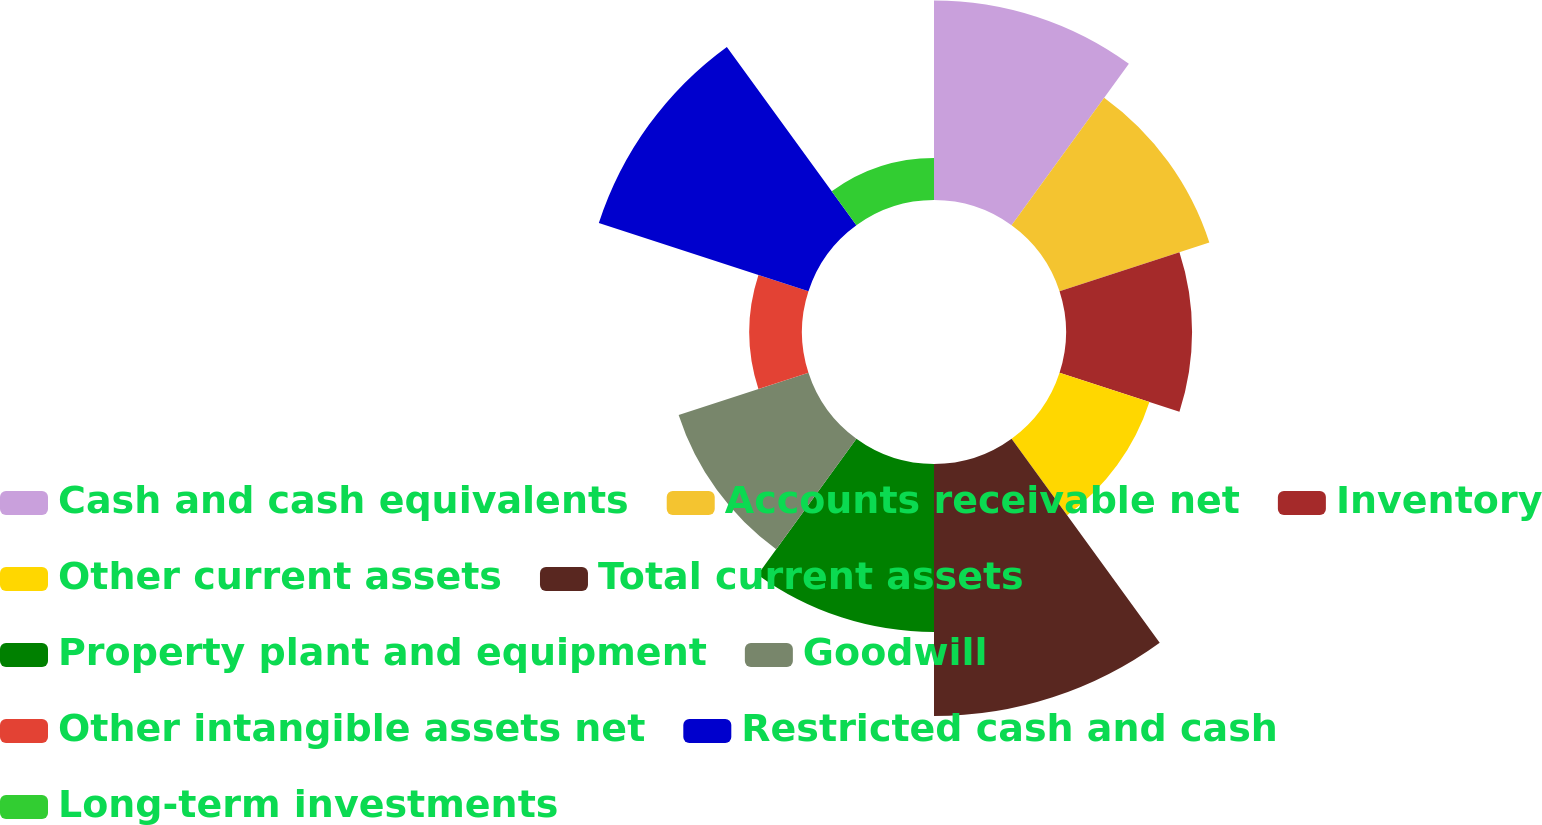Convert chart. <chart><loc_0><loc_0><loc_500><loc_500><pie_chart><fcel>Cash and cash equivalents<fcel>Accounts receivable net<fcel>Inventory<fcel>Other current assets<fcel>Total current assets<fcel>Property plant and equipment<fcel>Goodwill<fcel>Other intangible assets net<fcel>Restricted cash and cash<fcel>Long-term investments<nl><fcel>13.77%<fcel>10.87%<fcel>8.7%<fcel>6.52%<fcel>17.39%<fcel>11.59%<fcel>9.42%<fcel>3.63%<fcel>15.21%<fcel>2.9%<nl></chart> 